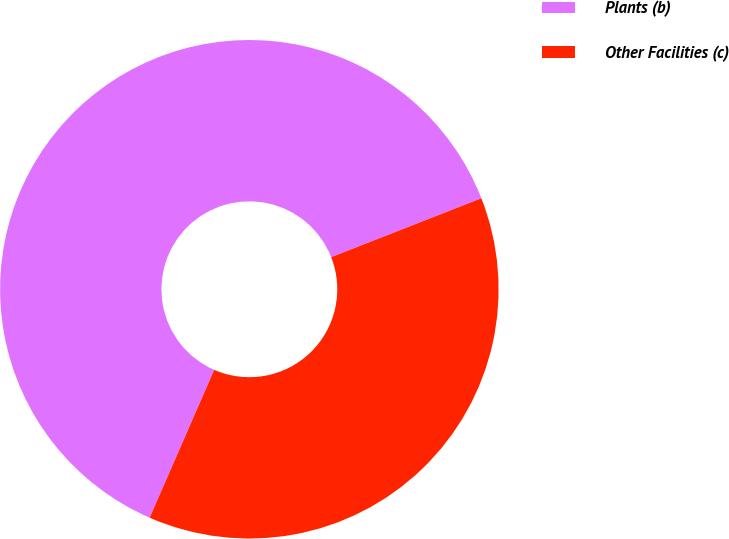Convert chart to OTSL. <chart><loc_0><loc_0><loc_500><loc_500><pie_chart><fcel>Plants (b)<fcel>Other Facilities (c)<nl><fcel>62.5%<fcel>37.5%<nl></chart> 